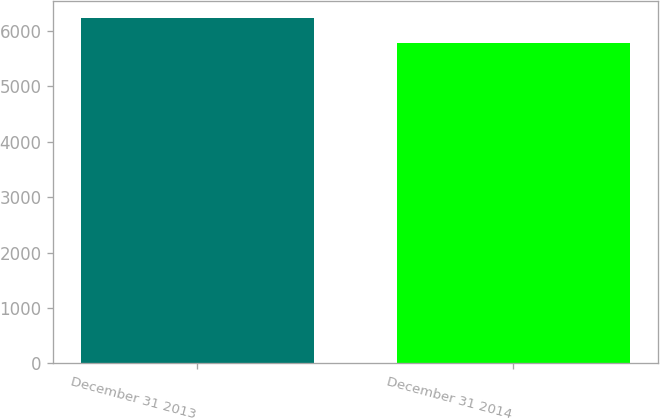<chart> <loc_0><loc_0><loc_500><loc_500><bar_chart><fcel>December 31 2013<fcel>December 31 2014<nl><fcel>6225<fcel>5775<nl></chart> 